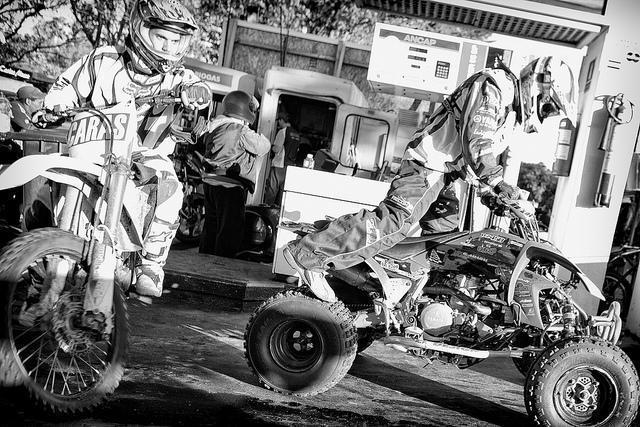What is the man on the right riding?
Indicate the correct response and explain using: 'Answer: answer
Rationale: rationale.'
Options: Scooter, quad, bicycle, motorcycle. Answer: quad.
Rationale: The man on the right is riding a quad bike. 